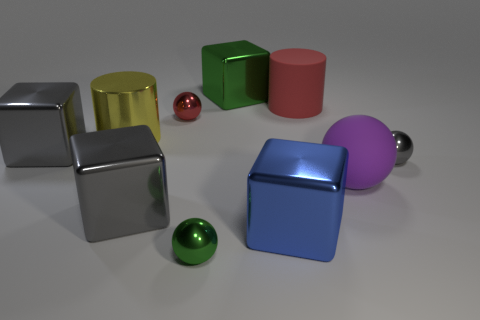What number of gray objects are there?
Keep it short and to the point. 3. What number of rubber balls have the same color as the large rubber cylinder?
Provide a short and direct response. 0. Do the large matte object left of the large rubber sphere and the green thing that is in front of the small red thing have the same shape?
Give a very brief answer. No. What color is the shiny ball behind the gray metal object on the right side of the gray shiny block in front of the purple rubber thing?
Ensure brevity in your answer.  Red. What color is the tiny ball in front of the small gray ball?
Offer a terse response. Green. What is the color of the sphere that is the same size as the green metallic cube?
Your answer should be very brief. Purple. Does the green block have the same size as the gray metal ball?
Keep it short and to the point. No. How many tiny gray spheres are in front of the tiny green ball?
Make the answer very short. 0. How many things are big metallic things that are behind the big ball or green shiny objects?
Your response must be concise. 4. Is the number of big rubber things that are in front of the big yellow cylinder greater than the number of purple objects that are behind the red shiny sphere?
Give a very brief answer. Yes. 